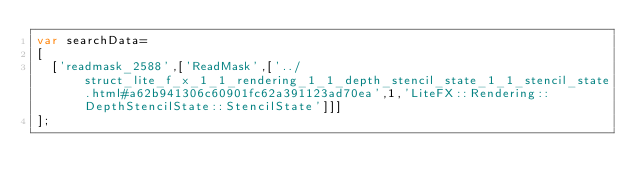Convert code to text. <code><loc_0><loc_0><loc_500><loc_500><_JavaScript_>var searchData=
[
  ['readmask_2588',['ReadMask',['../struct_lite_f_x_1_1_rendering_1_1_depth_stencil_state_1_1_stencil_state.html#a62b941306c60901fc62a391123ad70ea',1,'LiteFX::Rendering::DepthStencilState::StencilState']]]
];
</code> 